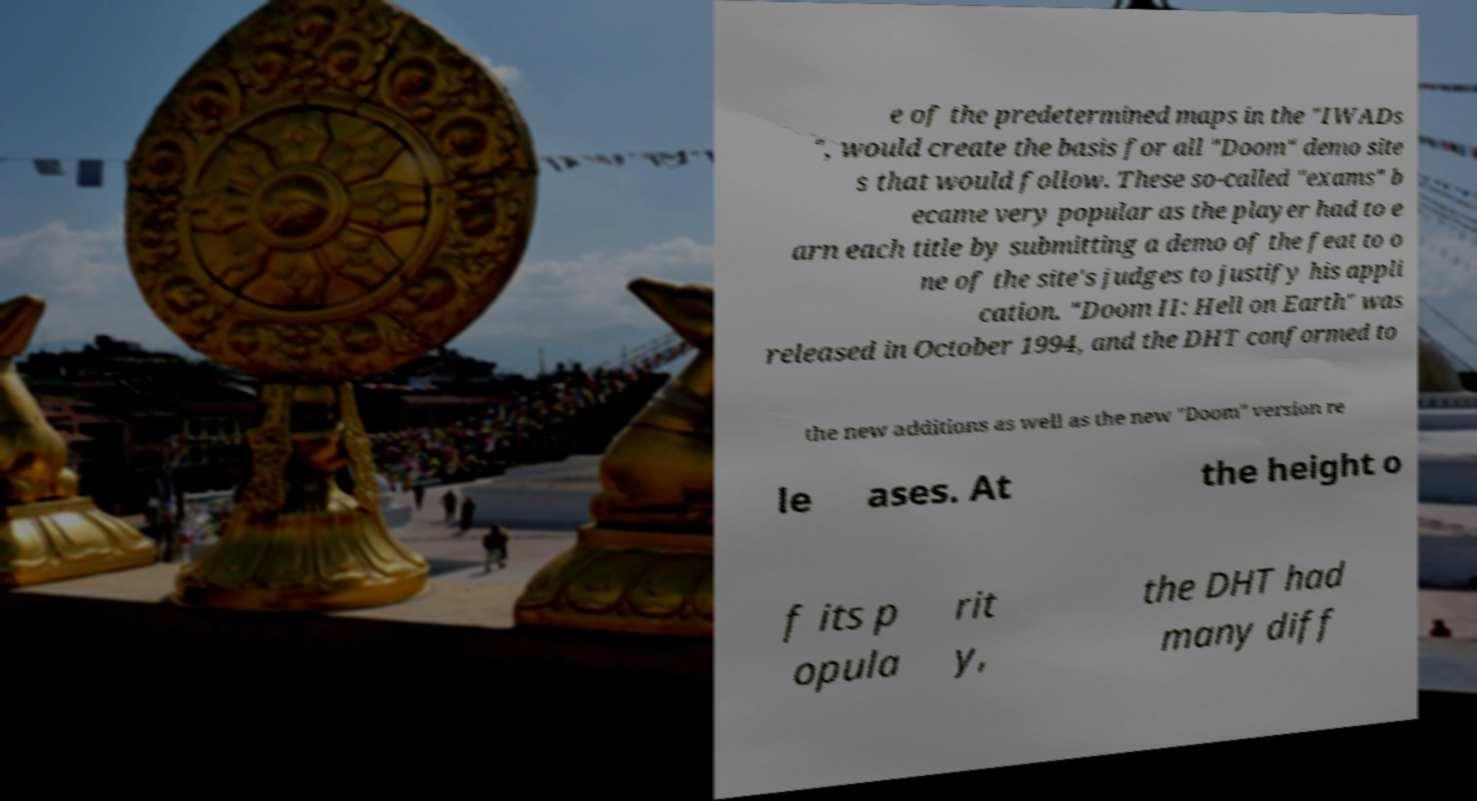Please identify and transcribe the text found in this image. e of the predetermined maps in the "IWADs ", would create the basis for all "Doom" demo site s that would follow. These so-called "exams" b ecame very popular as the player had to e arn each title by submitting a demo of the feat to o ne of the site's judges to justify his appli cation. "Doom II: Hell on Earth" was released in October 1994, and the DHT conformed to the new additions as well as the new "Doom" version re le ases. At the height o f its p opula rit y, the DHT had many diff 